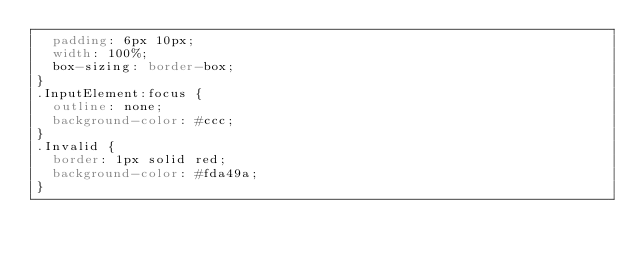<code> <loc_0><loc_0><loc_500><loc_500><_CSS_>  padding: 6px 10px;
  width: 100%;
  box-sizing: border-box;
}
.InputElement:focus {
  outline: none;
  background-color: #ccc;
}
.Invalid {
  border: 1px solid red;
  background-color: #fda49a;
}
</code> 